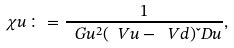Convert formula to latex. <formula><loc_0><loc_0><loc_500><loc_500>\chi u \colon = \frac { 1 } { \ G u ^ { 2 } ( \ V u - \ V d ) \L D u } ,</formula> 